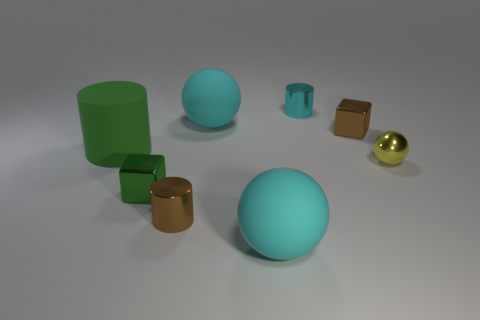Can you tell me which shapes in the image are geometrically similar? The two spheres are geometrically similar as they share the same shape in different sizes, and the two cylinders share a similar geometric shape as well. 